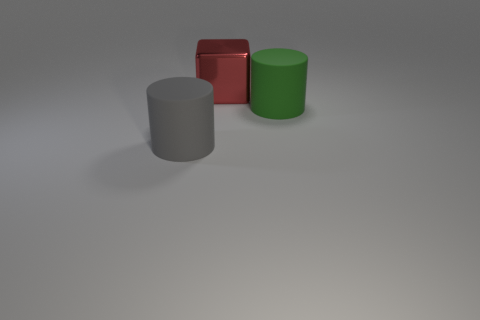The shiny block is what size?
Your answer should be very brief. Large. What number of red things are objects or metallic objects?
Ensure brevity in your answer.  1. There is a metallic thing behind the big thing that is in front of the green matte thing; what size is it?
Provide a succinct answer. Large. Does the shiny object have the same color as the large rubber thing that is to the left of the large metallic block?
Provide a succinct answer. No. What number of other things are made of the same material as the large cube?
Your answer should be very brief. 0. Is there any other thing of the same color as the block?
Your answer should be compact. No. Are there more large blocks that are in front of the large gray matte cylinder than blue metal things?
Your answer should be very brief. No. Does the green thing have the same shape as the large gray rubber object that is to the left of the big metallic object?
Your answer should be compact. Yes. How many other red metal cubes are the same size as the red metal cube?
Make the answer very short. 0. There is a thing in front of the rubber object right of the red thing; what number of gray matte cylinders are to the left of it?
Your response must be concise. 0. 